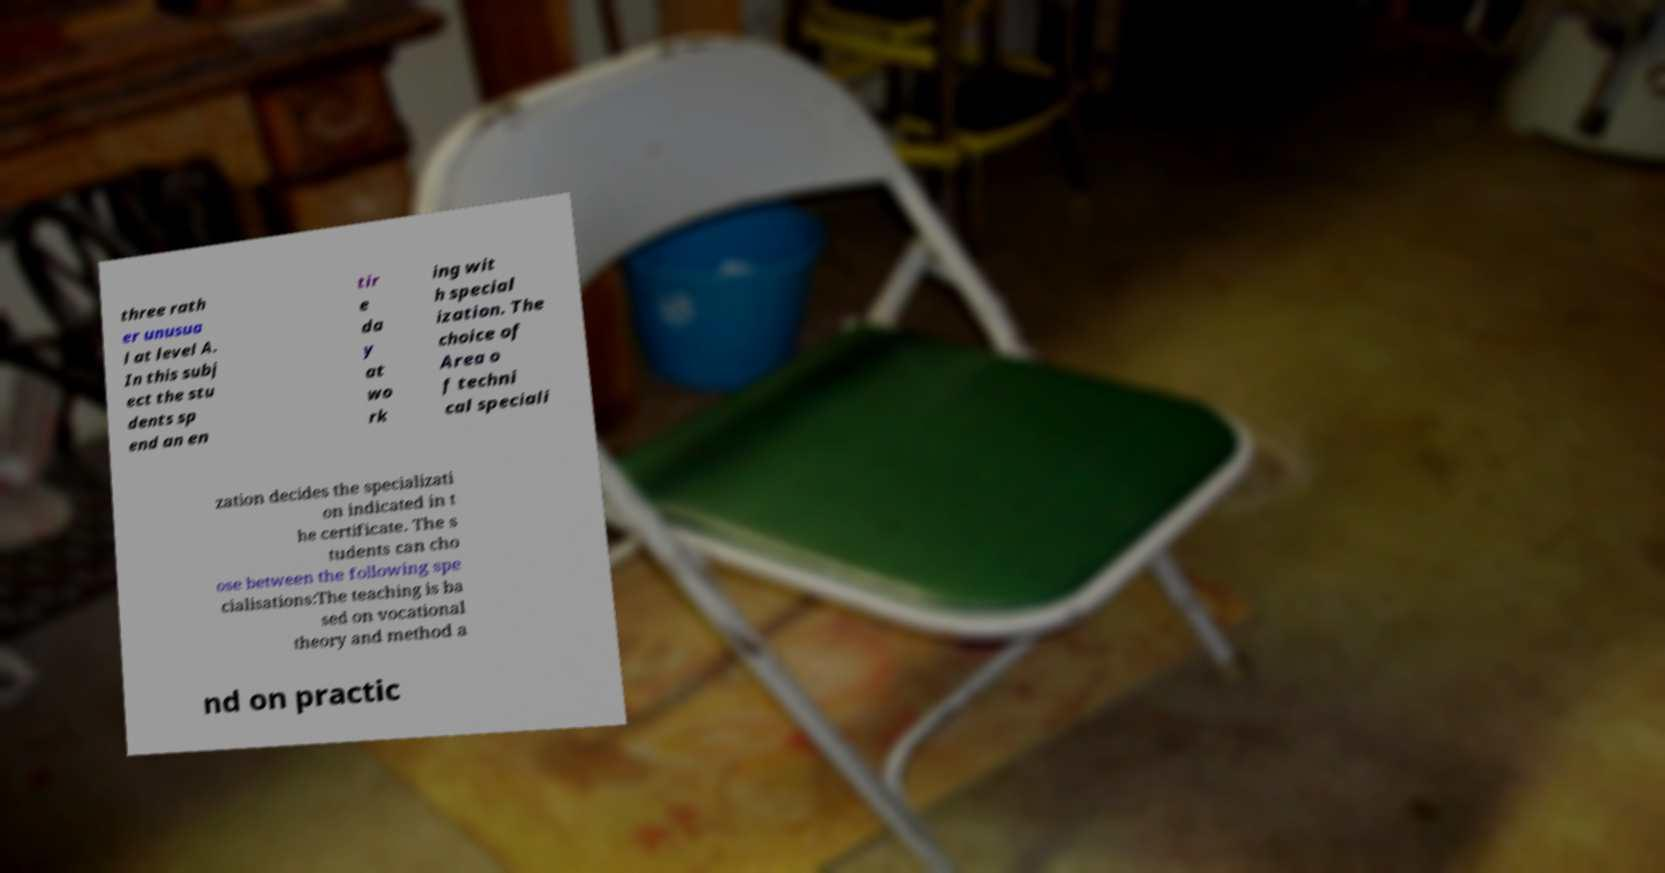Could you extract and type out the text from this image? three rath er unusua l at level A. In this subj ect the stu dents sp end an en tir e da y at wo rk ing wit h special ization. The choice of Area o f techni cal speciali zation decides the specializati on indicated in t he certificate. The s tudents can cho ose between the following spe cialisations:The teaching is ba sed on vocational theory and method a nd on practic 